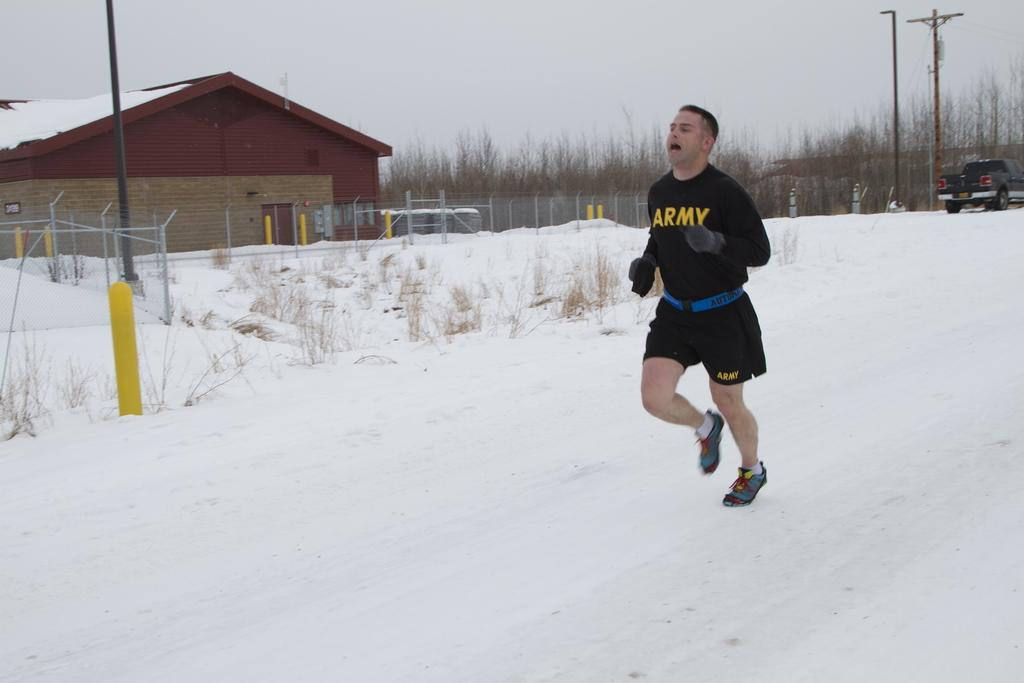<image>
Provide a brief description of the given image. A guy is running in a Army sweatshirt in the snow. 